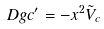Convert formula to latex. <formula><loc_0><loc_0><loc_500><loc_500>\ D g { c } ^ { \prime } = - x ^ { 2 } \tilde { V } _ { c }</formula> 